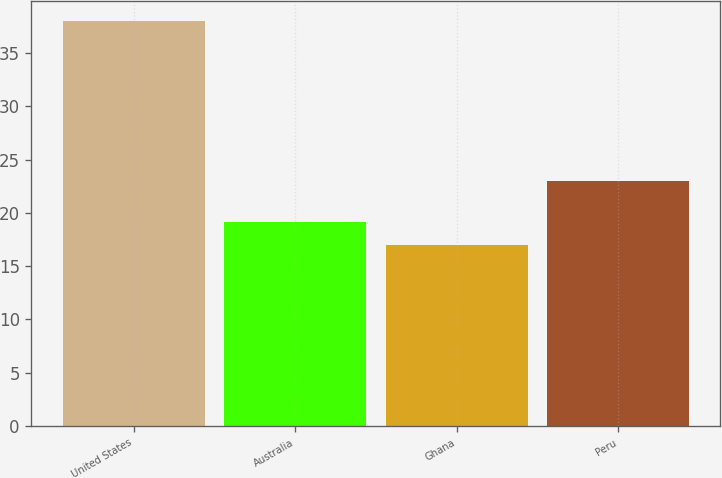Convert chart to OTSL. <chart><loc_0><loc_0><loc_500><loc_500><bar_chart><fcel>United States<fcel>Australia<fcel>Ghana<fcel>Peru<nl><fcel>38<fcel>19.1<fcel>17<fcel>23<nl></chart> 